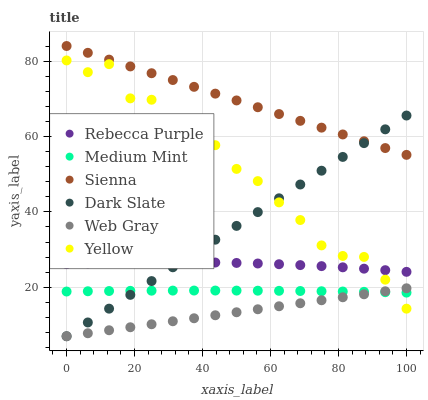Does Web Gray have the minimum area under the curve?
Answer yes or no. Yes. Does Sienna have the maximum area under the curve?
Answer yes or no. Yes. Does Yellow have the minimum area under the curve?
Answer yes or no. No. Does Yellow have the maximum area under the curve?
Answer yes or no. No. Is Web Gray the smoothest?
Answer yes or no. Yes. Is Yellow the roughest?
Answer yes or no. Yes. Is Yellow the smoothest?
Answer yes or no. No. Is Web Gray the roughest?
Answer yes or no. No. Does Web Gray have the lowest value?
Answer yes or no. Yes. Does Yellow have the lowest value?
Answer yes or no. No. Does Sienna have the highest value?
Answer yes or no. Yes. Does Web Gray have the highest value?
Answer yes or no. No. Is Web Gray less than Sienna?
Answer yes or no. Yes. Is Rebecca Purple greater than Medium Mint?
Answer yes or no. Yes. Does Medium Mint intersect Dark Slate?
Answer yes or no. Yes. Is Medium Mint less than Dark Slate?
Answer yes or no. No. Is Medium Mint greater than Dark Slate?
Answer yes or no. No. Does Web Gray intersect Sienna?
Answer yes or no. No. 